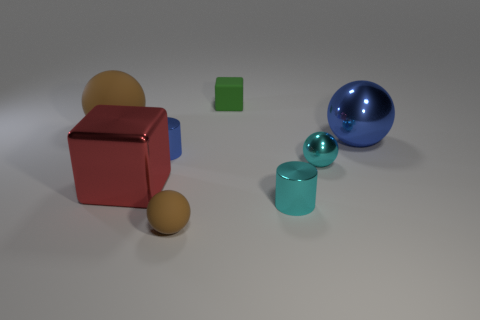The big red thing has what shape?
Your response must be concise. Cube. There is a small ball on the right side of the tiny rubber sphere; does it have the same color as the shiny object in front of the red block?
Give a very brief answer. Yes. Does the big red metal object have the same shape as the large brown matte thing?
Keep it short and to the point. No. Do the tiny object that is behind the big blue thing and the big blue object have the same material?
Offer a terse response. No. What is the shape of the matte object that is behind the blue sphere and in front of the green object?
Give a very brief answer. Sphere. There is a large metal thing that is left of the small green thing; are there any tiny shiny cylinders that are in front of it?
Offer a very short reply. Yes. What number of other objects are the same material as the green block?
Your response must be concise. 2. There is a blue thing that is to the right of the small green rubber cube; does it have the same shape as the matte object in front of the tiny cyan ball?
Your answer should be compact. Yes. Does the big block have the same material as the tiny cyan cylinder?
Your answer should be very brief. Yes. How big is the brown matte ball that is behind the large ball that is on the right side of the blue thing to the left of the tiny green rubber object?
Keep it short and to the point. Large. 